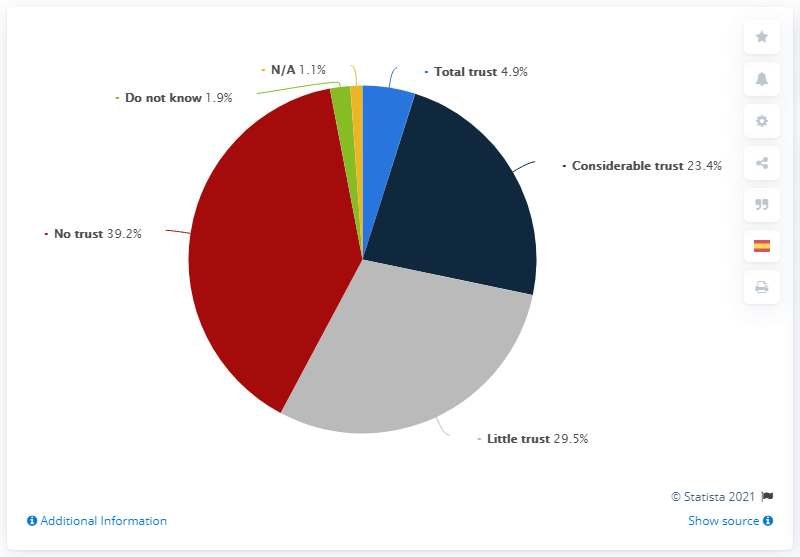What information might be missing from this chart that could provide more context? To gain a more comprehensive understanding, it would be helpful to know the demographics of the surveyed population, the specific subject or institution the trust levels are being measured against, and the time period during which the survey was conducted. Additional data on why individuals chose specific trust levels could also offer deeper insights. 